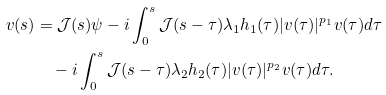Convert formula to latex. <formula><loc_0><loc_0><loc_500><loc_500>v ( s ) & = \mathcal { J } ( s ) \psi - i \int _ { 0 } ^ { s } \mathcal { J } ( s - \tau ) \lambda _ { 1 } h _ { 1 } ( \tau ) | v ( \tau ) | ^ { p _ { 1 } } v ( \tau ) d \tau \\ & \quad - i \int _ { 0 } ^ { s } \mathcal { J } ( s - \tau ) \lambda _ { 2 } h _ { 2 } ( \tau ) | v ( \tau ) | ^ { p _ { 2 } } v ( \tau ) d \tau .</formula> 